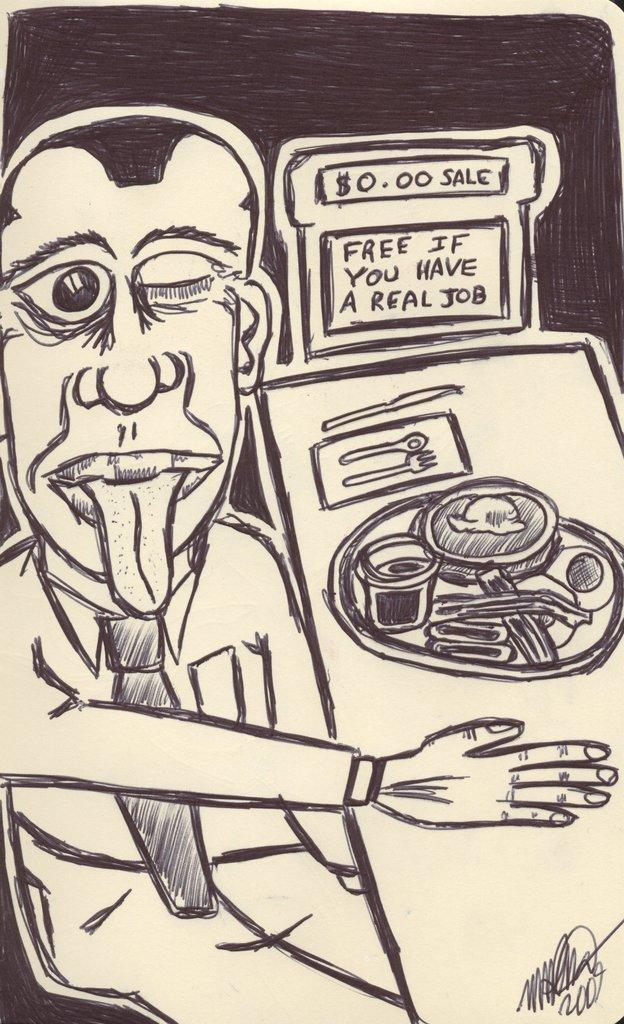What is the main subject of the image? The image contains a sketch. Who or what is depicted in the sketch? The sketch includes a man. What is the man doing in the sketch? The man is sitting in front of a table. What can be seen on the table in the sketch? There are food items on the table. What type of harbor can be seen in the background of the sketch? There is no harbor visible in the sketch; it only shows a man sitting in front of a table with food items. 